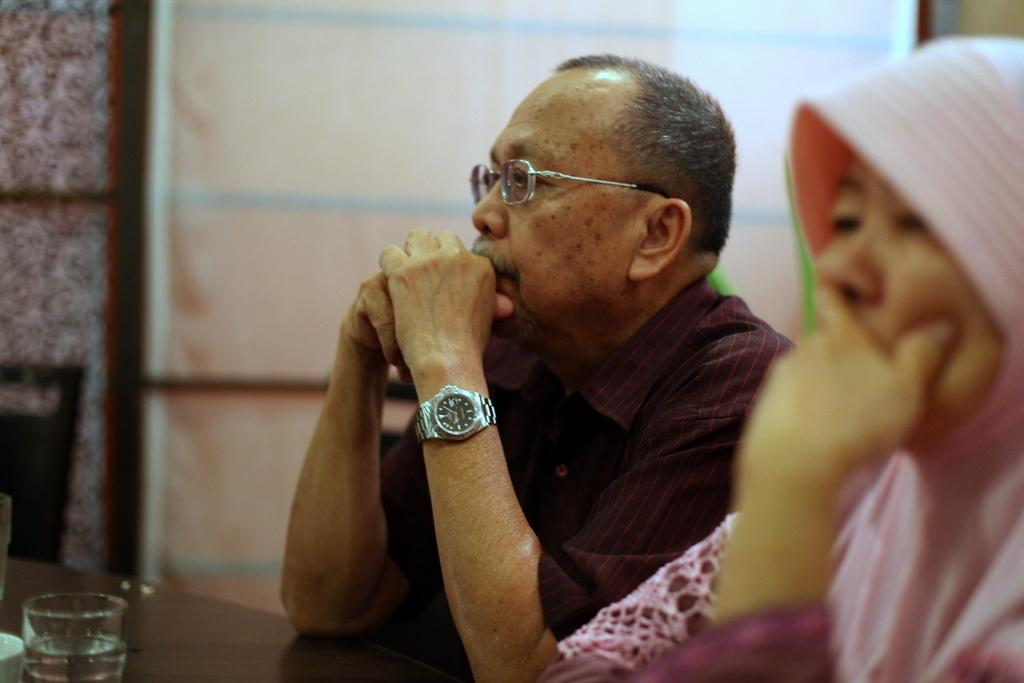How many people are present in the image? There are two people sitting in the image. What is in front of the people? There is a table in front of the people. What is on the table? There is a glass on the table. What is visible behind the people? There is a wall behind the people. What is behind the wall? We cannot see what is behind the wall from the image. What is behind the people, other than the wall? There is a chair behind the people. What type of waves can be seen crashing on the shore in the image? There are no waves or shore visible in the image; it features two people sitting at a table with a glass and a chair behind them. 